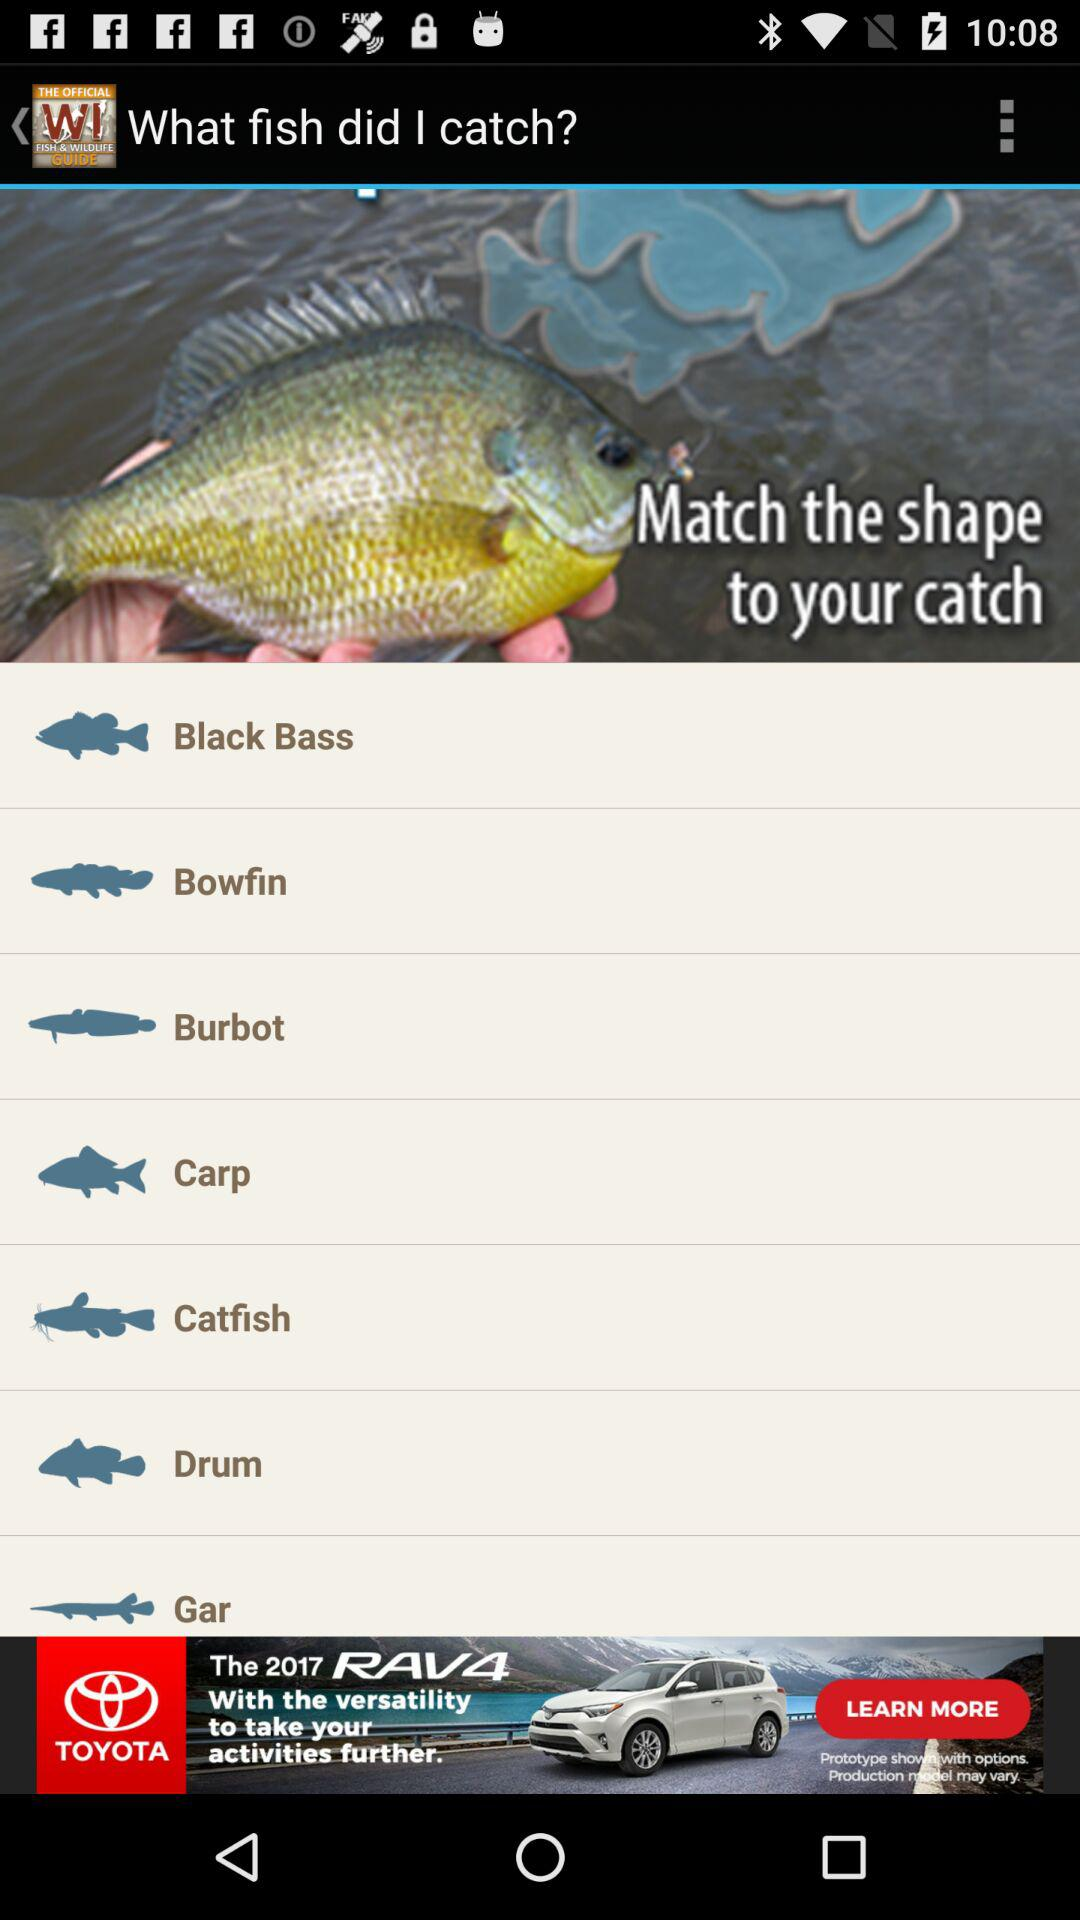Which fish is selected?
When the provided information is insufficient, respond with <no answer>. <no answer> 